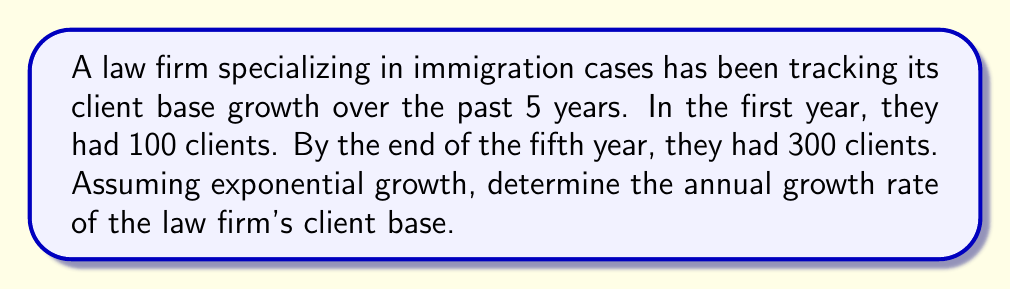What is the answer to this math problem? To solve this problem, we'll use the exponential growth formula:

$$A = P(1 + r)^t$$

Where:
$A$ = Final amount (300 clients)
$P$ = Initial amount (100 clients)
$r$ = Annual growth rate (what we're solving for)
$t$ = Time period (5 years)

Let's substitute the known values:

$$300 = 100(1 + r)^5$$

Now, we'll solve for $r$:

1) Divide both sides by 100:
   $$3 = (1 + r)^5$$

2) Take the fifth root of both sides:
   $$\sqrt[5]{3} = 1 + r$$

3) Subtract 1 from both sides:
   $$\sqrt[5]{3} - 1 = r$$

4) Calculate the value:
   $$r \approx 1.2457 - 1 = 0.2457$$

5) Convert to a percentage:
   $$r \approx 24.57\%$$
Answer: The annual growth rate of the law firm's client base is approximately 24.57%. 